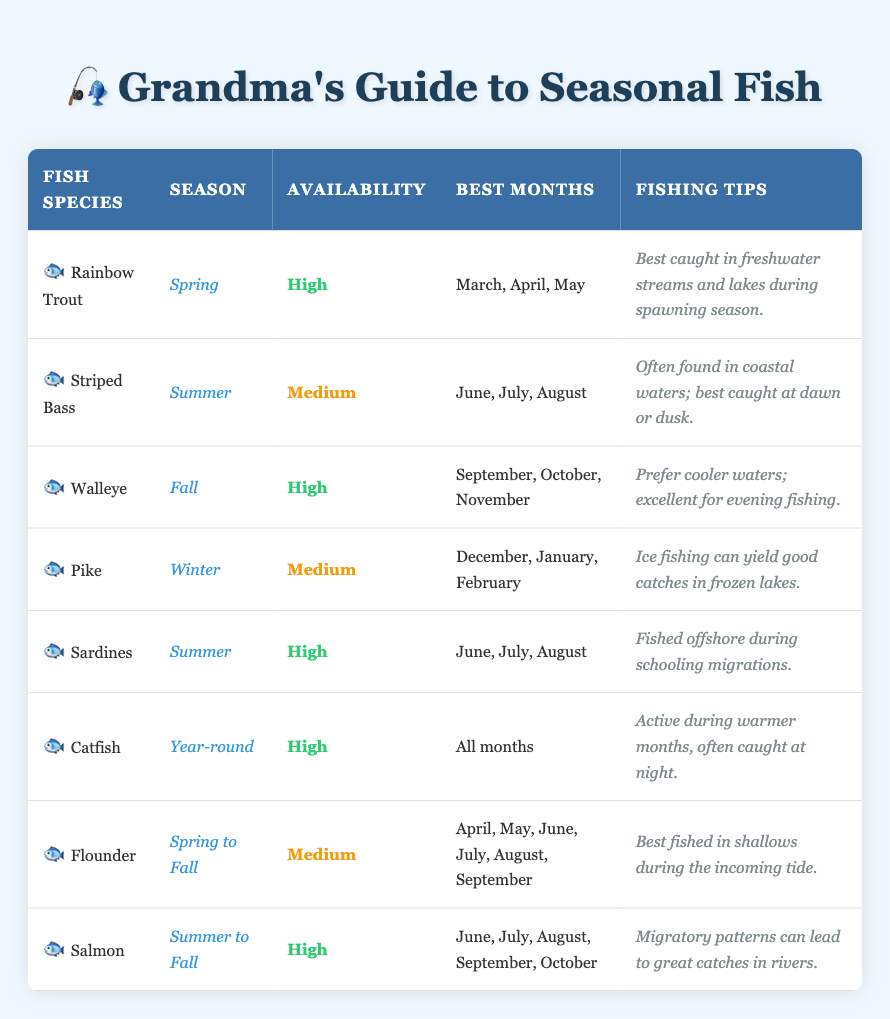What season is best for fishing for Rainbow Trout? The table lists Rainbow Trout under the season 'Spring', indicating that it is best to fish for this species during this time.
Answer: Spring How many fish species are available year-round? The table shows that Catfish is the only fish species marked as available year-round.
Answer: 1 Which fish species have a high availability in the summer? The table indicates that both Sardines and Salmon have a high availability during the summer season.
Answer: Sardines and Salmon What months are recommended for catching Walleye? The table specifies that September, October, and November are the best months for catching Walleye.
Answer: September, October, November Is it true that you can catch Pike in the summer? The table indicates that Pike is listed under the winter season, which means it is not available in the summer.
Answer: No Which fish species can be fished from spring to fall? The table shows Flounder as the species available from spring to fall, making it the answer.
Answer: Flounder During which months is Catfish most active? Although Catfish are available year-round, the notes suggest they are particularly active during warmer months, meaning they are easier to catch in the summer.
Answer: Warmer months (summer) What is the availability level of Striped Bass? The table categorizes Striped Bass as having medium availability, which is reflected in the corresponding column.
Answer: Medium If I want to catch fish with high availability in the fall, which two species should I target? The table indicates that both Walleye and Salmon have high availability in the fall months of September, October, and November.
Answer: Walleye and Salmon Which fish species are best caught during the evening? The table specifies that Walleye prefer evening fishing, suggesting this timing for catching that species.
Answer: Walleye What are the best months to catch Salmon? According to the table, the best months to catch Salmon are June, July, August, September, and October.
Answer: June, July, August, September, October Is Pike a high availability fish species? The table shows that Pike has a medium availability, indicating that it is not categorized as high availability.
Answer: No 